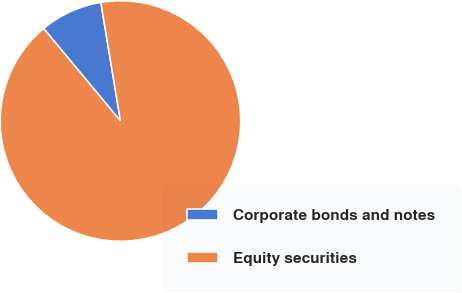<chart> <loc_0><loc_0><loc_500><loc_500><pie_chart><fcel>Corporate bonds and notes<fcel>Equity securities<nl><fcel>8.42%<fcel>91.58%<nl></chart> 